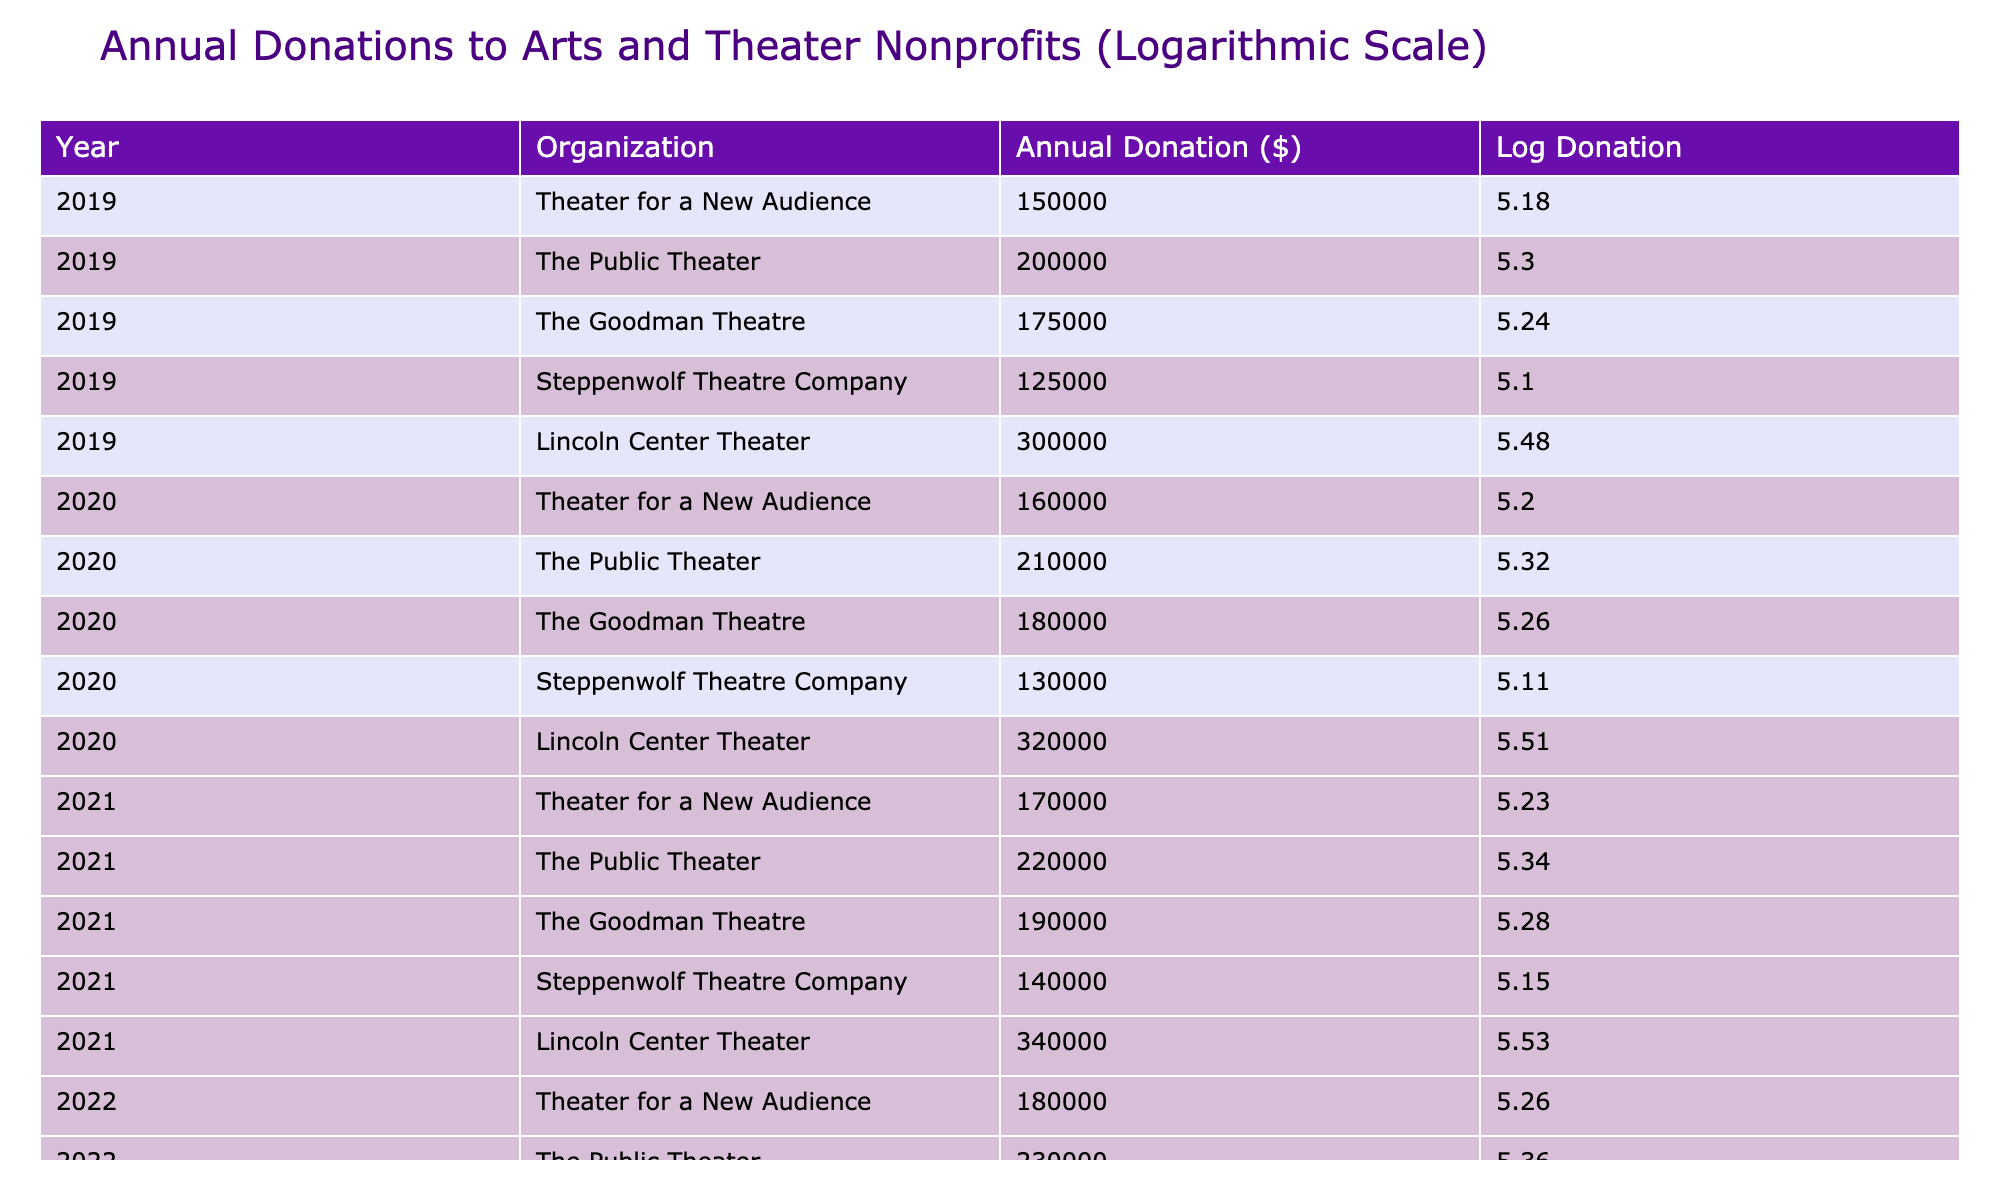What was the annual donation amount for the Goodman Theatre in 2021? From the table, we can locate the row corresponding to the Goodman Theatre for the year 2021, which shows an annual donation amount of $190,000.
Answer: $190,000 What is the total annual donation received by Lincoln Center Theater over the five years? To find the total, we take the donations for each year: 300000 + 320000 + 340000 + 360000 + 380000 = 1,700,000.
Answer: $1,700,000 Did the annual donation for Theater for a New Audience increase every year? Reviewing the donations, we see the annual amounts: 150000, 160000, 170000, 180000, and 190000. Since all values are higher than the preceding year, the donation did increase every year.
Answer: Yes What was the greatest difference in annual donation for Steppenwolf Theatre Company between any two consecutive years? We assess the donations: 125000 (2019), 130000 (2020), 140000 (2021), 150000 (2022), 160000 (2023). The differences are: 5000 (19-20), 10000 (20-21), 10000 (21-22), 10000 (22-23). The greatest difference is 10000 between 2020 and 2023.
Answer: $10,000 What is the average annual donation for The Public Theater over the five years? The donations for The Public Theater are 200000, 210000, 220000, 230000, and 240000. Summing these gives 1,110,000. Dividing this by 5 yields an average of 222,000.
Answer: $222,000 What was the annual donation for the year 2020 across all organizations? To find the total donation for 2020, we sum the values for that year: 160000 (Theater for a New Audience) + 210000 (The Public Theater) + 180000 (The Goodman Theatre) + 130000 (Steppenwolf Theatre Company) + 320000 (Lincoln Center Theater), which totals to 1,000,000.
Answer: $1,000,000 Which organization had the highest annual donation in 2023? Looking at the 2023 row, Lincoln Center Theater received the highest donation of 380000 among all listed organizations.
Answer: Lincoln Center Theater Was the annual donation for The Goodman Theatre always less than for Lincoln Center Theater? Checking the donations: for Goodman Theatre (2019: 175000, 2020: 180000, 2021: 190000, 2022: 200000, 2023: 210000) against Lincoln Center Theatre (2019: 300000, 2020: 320000, 2021: 340000, 2022: 360000, 2023: 380000). The Goodman Theatre's donations are indeed less in every year.
Answer: Yes 